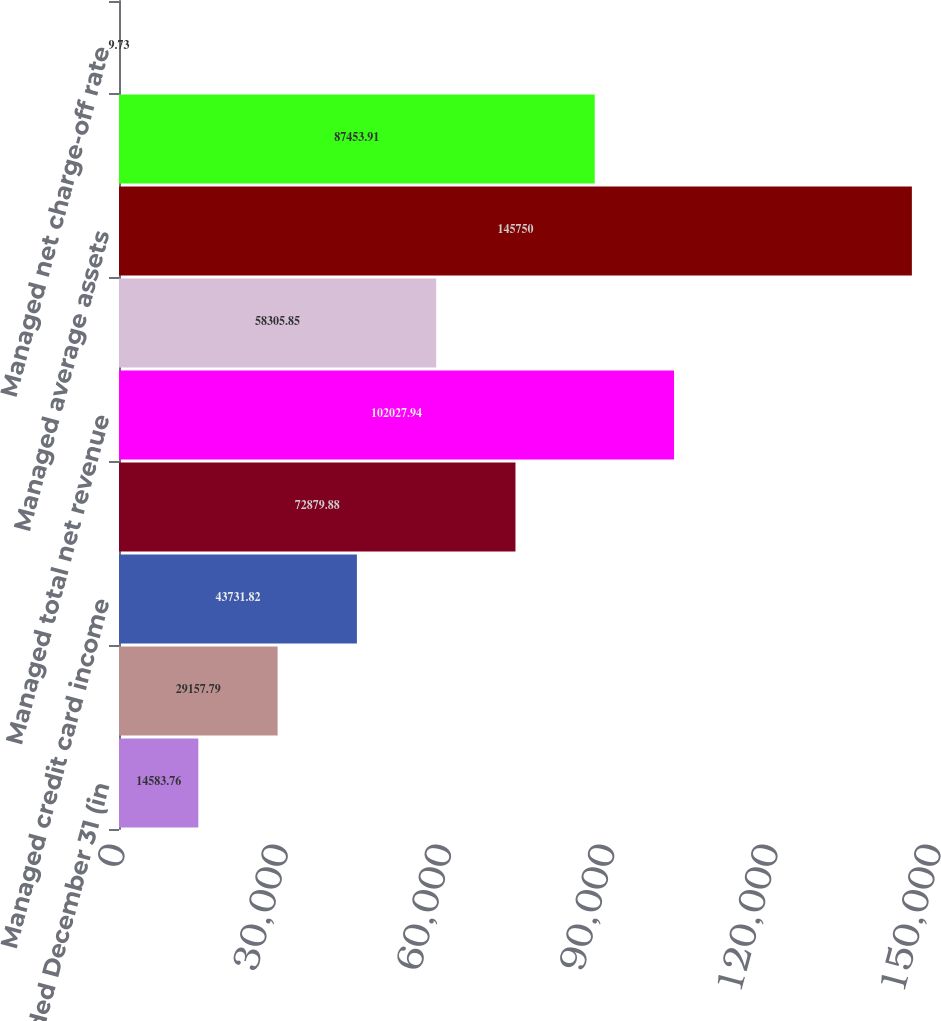<chart> <loc_0><loc_0><loc_500><loc_500><bar_chart><fcel>Year ended December 31 (in<fcel>Reported<fcel>Managed credit card income<fcel>Managed net interest income<fcel>Managed total net revenue<fcel>Managed provision for credit<fcel>Managed average assets<fcel>Managed net charge-offs<fcel>Managed net charge-off rate<nl><fcel>14583.8<fcel>29157.8<fcel>43731.8<fcel>72879.9<fcel>102028<fcel>58305.8<fcel>145750<fcel>87453.9<fcel>9.73<nl></chart> 